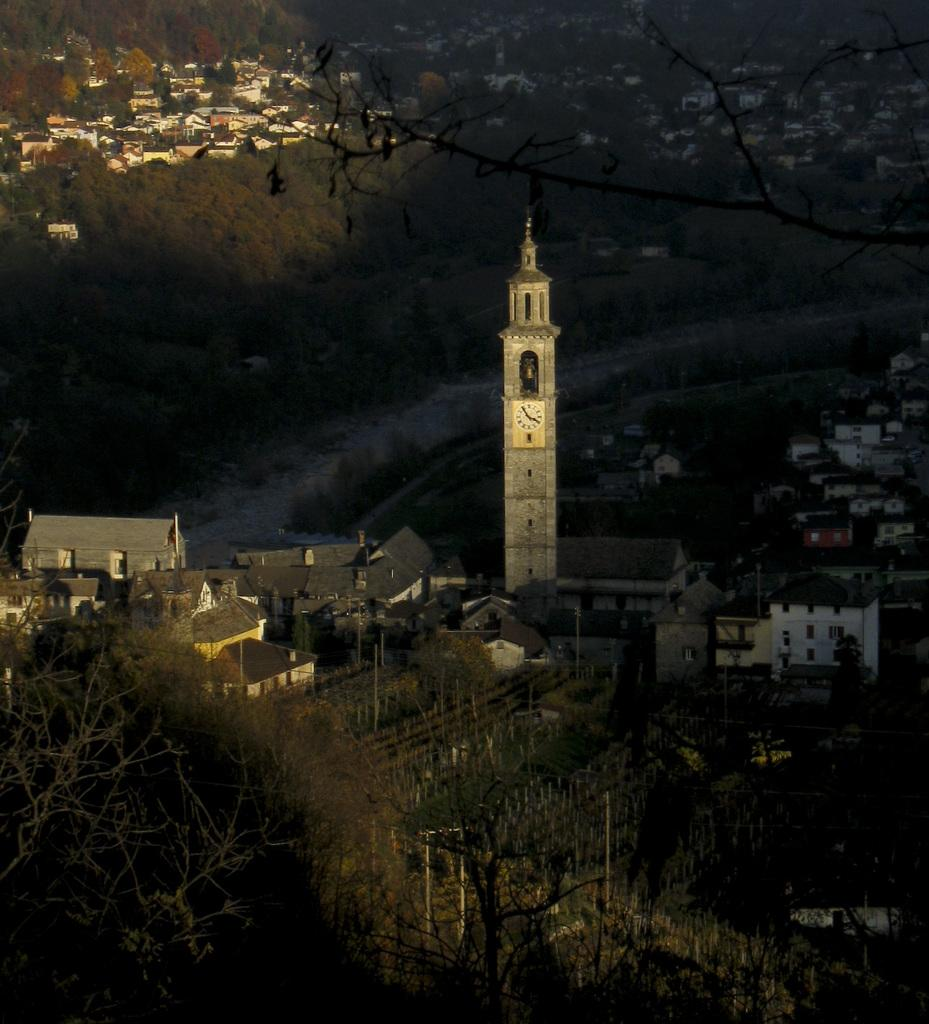What type of structures can be seen in the image? There are buildings in the image. What natural elements are present in the image? There are trees in the image. Can you describe any other objects or features in the image? There are other objects in the image, but their specific details are not mentioned in the provided facts. How many bottles of water are visible in the image? There is no mention of bottles of water in the provided facts, so it cannot be determined from the image. 